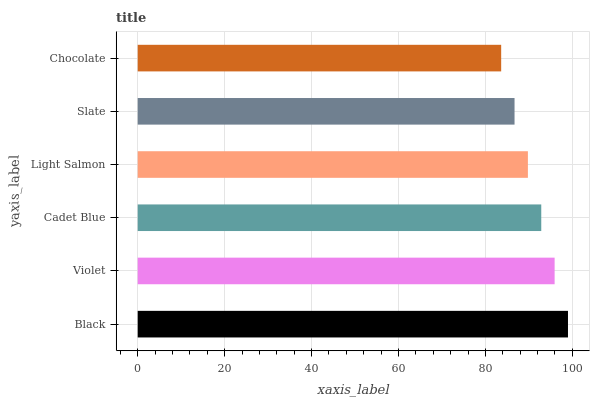Is Chocolate the minimum?
Answer yes or no. Yes. Is Black the maximum?
Answer yes or no. Yes. Is Violet the minimum?
Answer yes or no. No. Is Violet the maximum?
Answer yes or no. No. Is Black greater than Violet?
Answer yes or no. Yes. Is Violet less than Black?
Answer yes or no. Yes. Is Violet greater than Black?
Answer yes or no. No. Is Black less than Violet?
Answer yes or no. No. Is Cadet Blue the high median?
Answer yes or no. Yes. Is Light Salmon the low median?
Answer yes or no. Yes. Is Violet the high median?
Answer yes or no. No. Is Slate the low median?
Answer yes or no. No. 